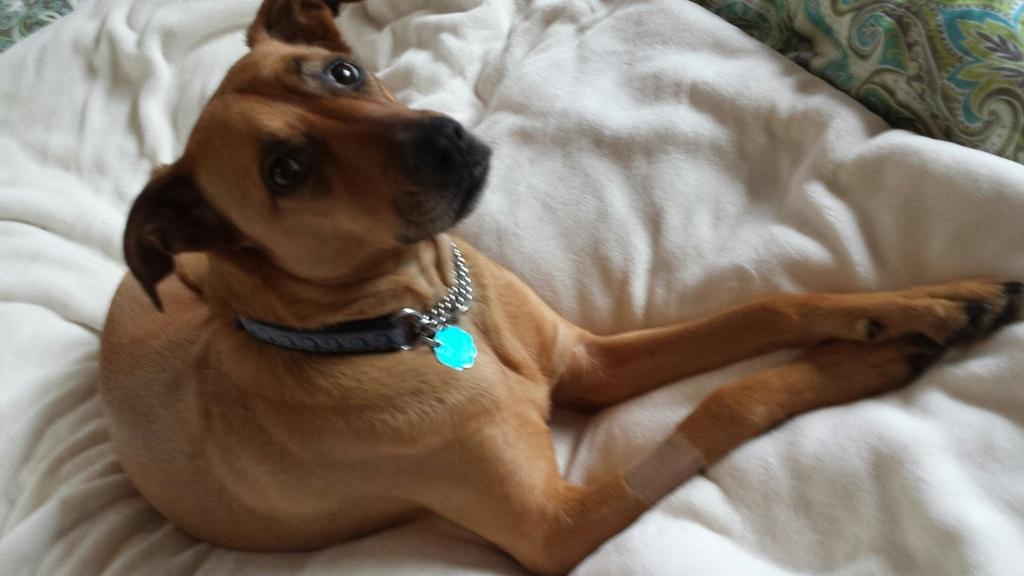What is located at the bottom of the image? There is a bed at the bottom of the image. What is covering the bed? The bed has a bed sheet on it. What can be seen in the middle of the image? A dog is lying on a white cloth in the middle of the image. What type of education can be seen in the image? There is no reference to education in the image; it features a bed, a bed sheet, and a dog lying on a white cloth. 